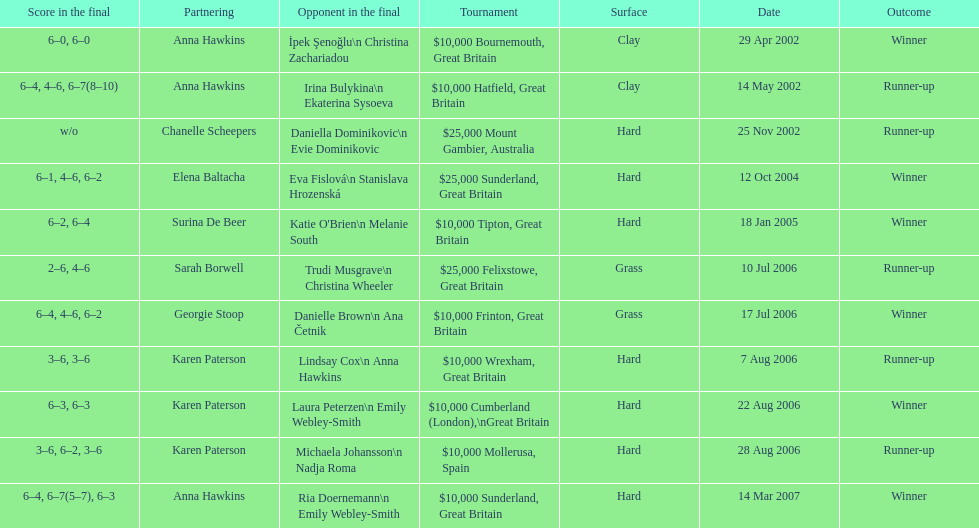How many surfaces are grass? 2. Help me parse the entirety of this table. {'header': ['Score in the final', 'Partnering', 'Opponent in the final', 'Tournament', 'Surface', 'Date', 'Outcome'], 'rows': [['6–0, 6–0', 'Anna Hawkins', 'İpek Şenoğlu\\n Christina Zachariadou', '$10,000 Bournemouth, Great Britain', 'Clay', '29 Apr 2002', 'Winner'], ['6–4, 4–6, 6–7(8–10)', 'Anna Hawkins', 'Irina Bulykina\\n Ekaterina Sysoeva', '$10,000 Hatfield, Great Britain', 'Clay', '14 May 2002', 'Runner-up'], ['w/o', 'Chanelle Scheepers', 'Daniella Dominikovic\\n Evie Dominikovic', '$25,000 Mount Gambier, Australia', 'Hard', '25 Nov 2002', 'Runner-up'], ['6–1, 4–6, 6–2', 'Elena Baltacha', 'Eva Fislová\\n Stanislava Hrozenská', '$25,000 Sunderland, Great Britain', 'Hard', '12 Oct 2004', 'Winner'], ['6–2, 6–4', 'Surina De Beer', "Katie O'Brien\\n Melanie South", '$10,000 Tipton, Great Britain', 'Hard', '18 Jan 2005', 'Winner'], ['2–6, 4–6', 'Sarah Borwell', 'Trudi Musgrave\\n Christina Wheeler', '$25,000 Felixstowe, Great Britain', 'Grass', '10 Jul 2006', 'Runner-up'], ['6–4, 4–6, 6–2', 'Georgie Stoop', 'Danielle Brown\\n Ana Četnik', '$10,000 Frinton, Great Britain', 'Grass', '17 Jul 2006', 'Winner'], ['3–6, 3–6', 'Karen Paterson', 'Lindsay Cox\\n Anna Hawkins', '$10,000 Wrexham, Great Britain', 'Hard', '7 Aug 2006', 'Runner-up'], ['6–3, 6–3', 'Karen Paterson', 'Laura Peterzen\\n Emily Webley-Smith', '$10,000 Cumberland (London),\\nGreat Britain', 'Hard', '22 Aug 2006', 'Winner'], ['3–6, 6–2, 3–6', 'Karen Paterson', 'Michaela Johansson\\n Nadja Roma', '$10,000 Mollerusa, Spain', 'Hard', '28 Aug 2006', 'Runner-up'], ['6–4, 6–7(5–7), 6–3', 'Anna Hawkins', 'Ria Doernemann\\n Emily Webley-Smith', '$10,000 Sunderland, Great Britain', 'Hard', '14 Mar 2007', 'Winner']]} 